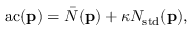<formula> <loc_0><loc_0><loc_500><loc_500>a c ( p ) = \bar { N } ( p ) + \kappa N _ { s t d } ( p ) ,</formula> 